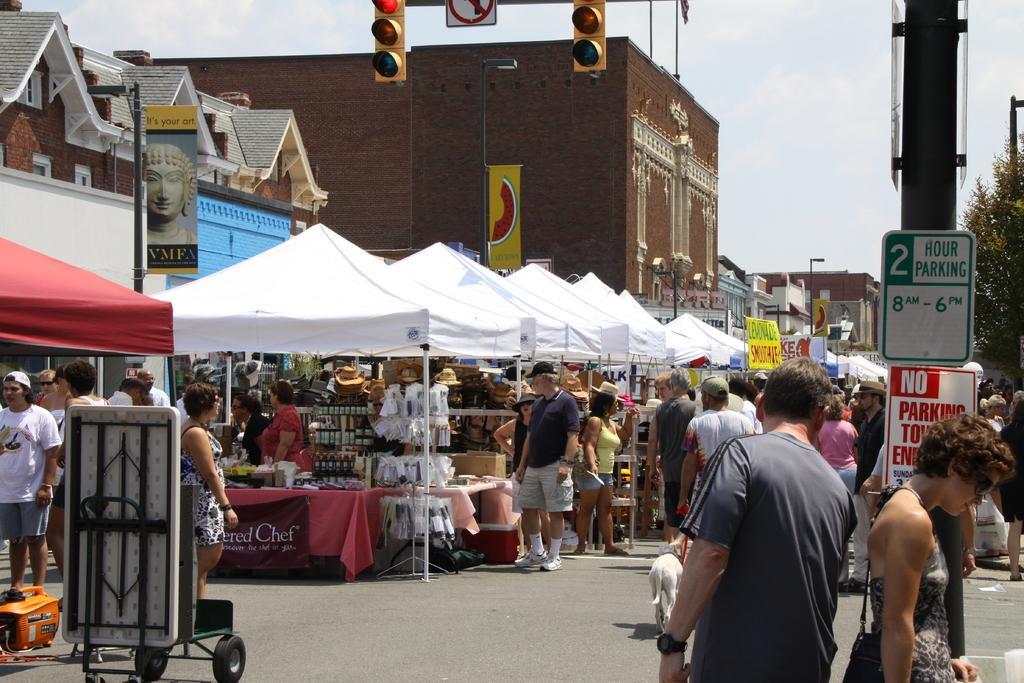Please provide a concise description of this image. The image is taken on the road. On the left side of the image we can see tents. In the center there are people standing. At the top there are traffic lights. In the background there are buildings, poles, boards and sky. On the right there is a tree. 